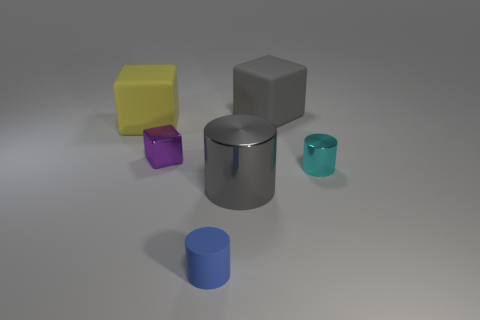Do the large metal object and the tiny blue rubber thing have the same shape?
Provide a short and direct response. Yes. Are there any gray objects that have the same shape as the small purple metallic thing?
Offer a very short reply. Yes. What shape is the purple metallic object that is the same size as the cyan metallic thing?
Your answer should be very brief. Cube. What material is the small cyan object that is to the right of the tiny object on the left side of the tiny object in front of the big cylinder?
Your answer should be very brief. Metal. Is the size of the gray cylinder the same as the blue cylinder?
Make the answer very short. No. What is the small cyan object made of?
Keep it short and to the point. Metal. There is a large block that is the same color as the big shiny cylinder; what material is it?
Provide a short and direct response. Rubber. There is a thing that is left of the small metallic cube; does it have the same shape as the large gray matte object?
Your answer should be very brief. Yes. How many objects are gray spheres or small rubber things?
Offer a terse response. 1. Does the tiny thing that is in front of the tiny cyan thing have the same material as the small purple block?
Your answer should be compact. No. 